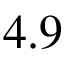<formula> <loc_0><loc_0><loc_500><loc_500>4 . 9</formula> 